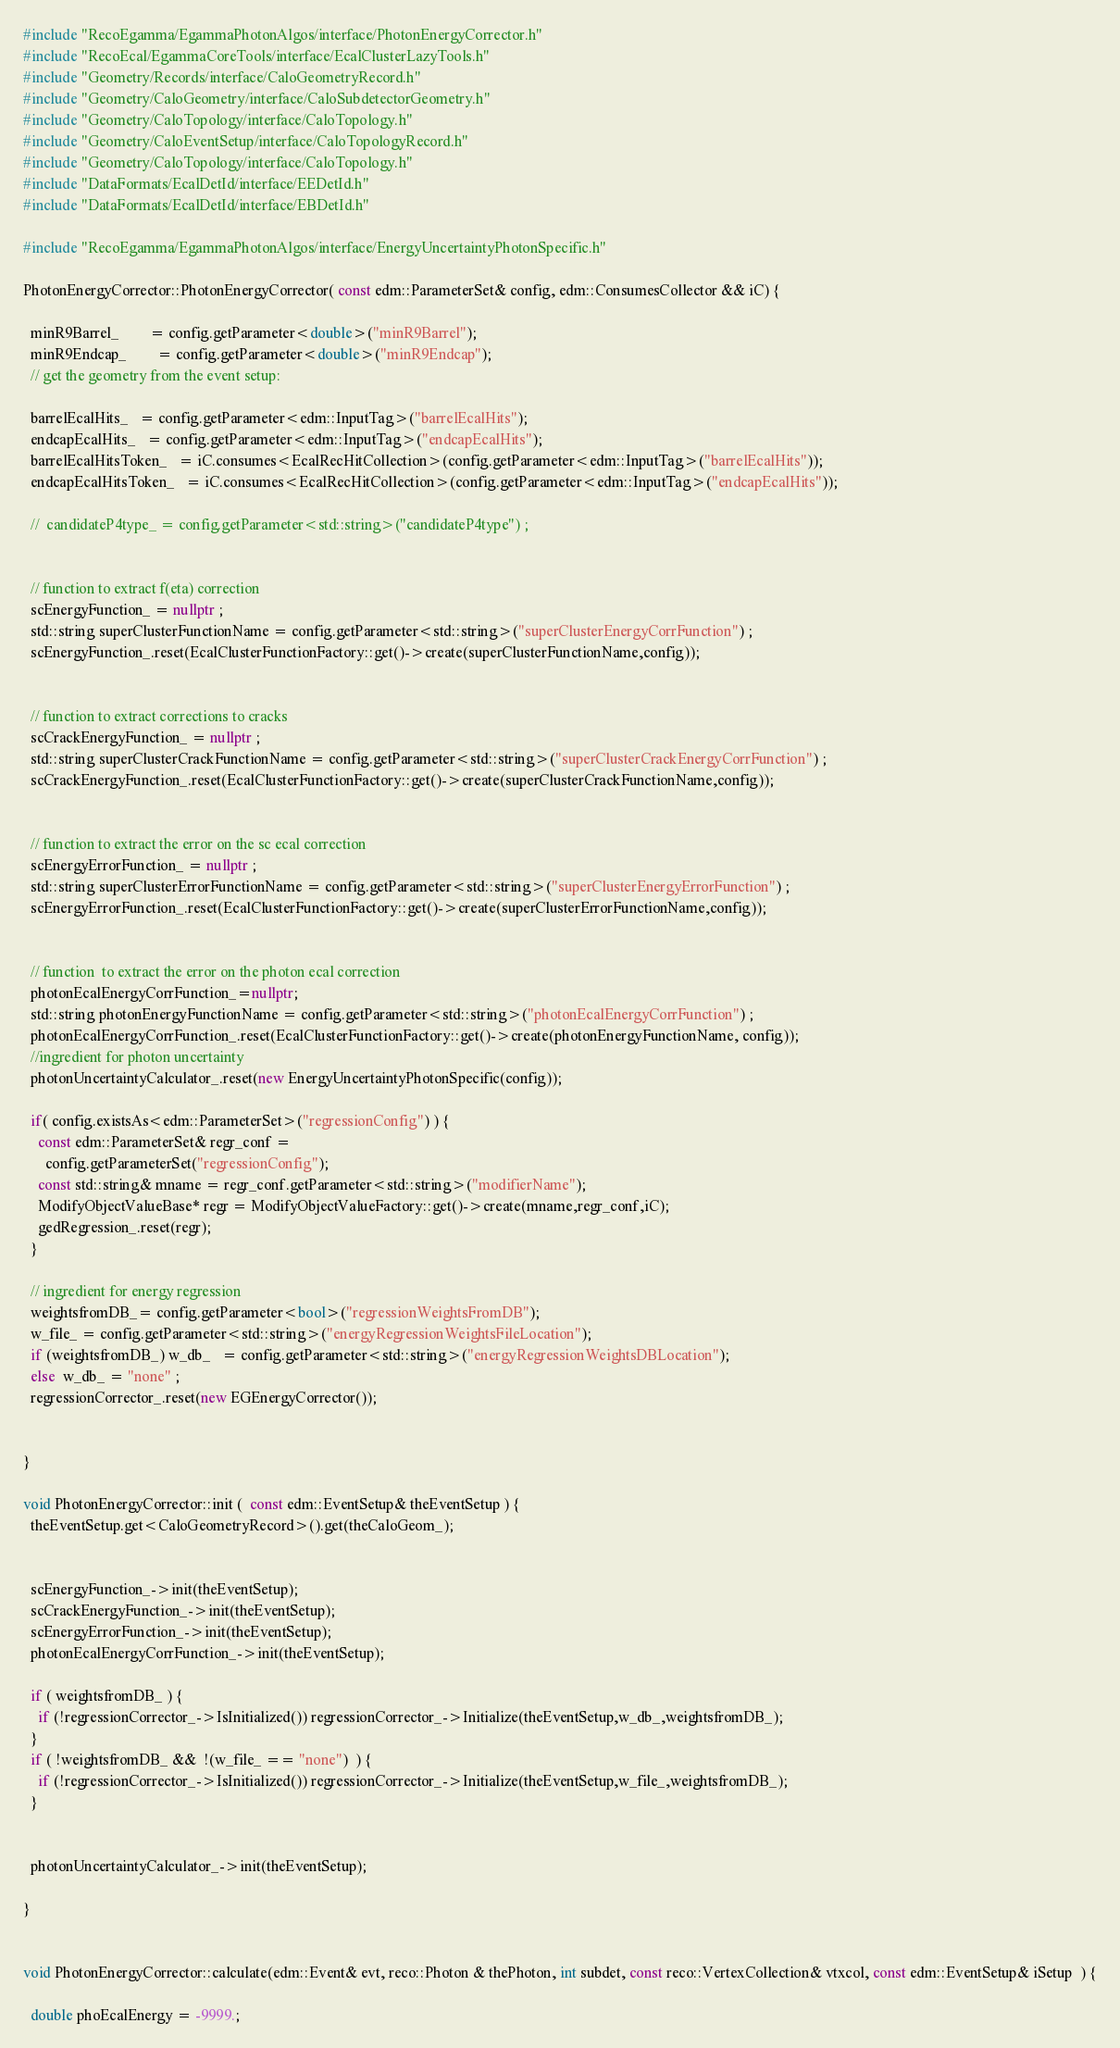Convert code to text. <code><loc_0><loc_0><loc_500><loc_500><_C++_>#include "RecoEgamma/EgammaPhotonAlgos/interface/PhotonEnergyCorrector.h"
#include "RecoEcal/EgammaCoreTools/interface/EcalClusterLazyTools.h"
#include "Geometry/Records/interface/CaloGeometryRecord.h"
#include "Geometry/CaloGeometry/interface/CaloSubdetectorGeometry.h"
#include "Geometry/CaloTopology/interface/CaloTopology.h"
#include "Geometry/CaloEventSetup/interface/CaloTopologyRecord.h"
#include "Geometry/CaloTopology/interface/CaloTopology.h"
#include "DataFormats/EcalDetId/interface/EEDetId.h"
#include "DataFormats/EcalDetId/interface/EBDetId.h"

#include "RecoEgamma/EgammaPhotonAlgos/interface/EnergyUncertaintyPhotonSpecific.h"

PhotonEnergyCorrector::PhotonEnergyCorrector( const edm::ParameterSet& config, edm::ConsumesCollector && iC) {

  minR9Barrel_        = config.getParameter<double>("minR9Barrel");
  minR9Endcap_        = config.getParameter<double>("minR9Endcap");
  // get the geometry from the event setup:

  barrelEcalHits_   = config.getParameter<edm::InputTag>("barrelEcalHits");
  endcapEcalHits_   = config.getParameter<edm::InputTag>("endcapEcalHits");
  barrelEcalHitsToken_   = iC.consumes<EcalRecHitCollection>(config.getParameter<edm::InputTag>("barrelEcalHits"));
  endcapEcalHitsToken_   = iC.consumes<EcalRecHitCollection>(config.getParameter<edm::InputTag>("endcapEcalHits"));

  //  candidateP4type_ = config.getParameter<std::string>("candidateP4type") ;


  // function to extract f(eta) correction
  scEnergyFunction_ = nullptr ;
  std::string superClusterFunctionName = config.getParameter<std::string>("superClusterEnergyCorrFunction") ;
  scEnergyFunction_.reset(EcalClusterFunctionFactory::get()->create(superClusterFunctionName,config));


  // function to extract corrections to cracks
  scCrackEnergyFunction_ = nullptr ;
  std::string superClusterCrackFunctionName = config.getParameter<std::string>("superClusterCrackEnergyCorrFunction") ;
  scCrackEnergyFunction_.reset(EcalClusterFunctionFactory::get()->create(superClusterCrackFunctionName,config));


  // function to extract the error on the sc ecal correction
  scEnergyErrorFunction_ = nullptr ;
  std::string superClusterErrorFunctionName = config.getParameter<std::string>("superClusterEnergyErrorFunction") ;
  scEnergyErrorFunction_.reset(EcalClusterFunctionFactory::get()->create(superClusterErrorFunctionName,config));


  // function  to extract the error on the photon ecal correction
  photonEcalEnergyCorrFunction_=nullptr;
  std::string photonEnergyFunctionName = config.getParameter<std::string>("photonEcalEnergyCorrFunction") ;
  photonEcalEnergyCorrFunction_.reset(EcalClusterFunctionFactory::get()->create(photonEnergyFunctionName, config));
  //ingredient for photon uncertainty
  photonUncertaintyCalculator_.reset(new EnergyUncertaintyPhotonSpecific(config));
 
  if( config.existsAs<edm::ParameterSet>("regressionConfig") ) {
    const edm::ParameterSet& regr_conf = 
      config.getParameterSet("regressionConfig");
    const std::string& mname = regr_conf.getParameter<std::string>("modifierName");
    ModifyObjectValueBase* regr = ModifyObjectValueFactory::get()->create(mname,regr_conf,iC);
    gedRegression_.reset(regr);
  }

  // ingredient for energy regression
  weightsfromDB_= config.getParameter<bool>("regressionWeightsFromDB");
  w_file_ = config.getParameter<std::string>("energyRegressionWeightsFileLocation");
  if (weightsfromDB_) w_db_   = config.getParameter<std::string>("energyRegressionWeightsDBLocation");
  else  w_db_ = "none" ;
  regressionCorrector_.reset(new EGEnergyCorrector()); 


}

void PhotonEnergyCorrector::init (  const edm::EventSetup& theEventSetup ) {
  theEventSetup.get<CaloGeometryRecord>().get(theCaloGeom_);


  scEnergyFunction_->init(theEventSetup); 
  scCrackEnergyFunction_->init(theEventSetup); 
  scEnergyErrorFunction_->init(theEventSetup); 
  photonEcalEnergyCorrFunction_->init(theEventSetup);

  if ( weightsfromDB_ ) {
    if (!regressionCorrector_->IsInitialized()) regressionCorrector_->Initialize(theEventSetup,w_db_,weightsfromDB_);
  }
  if ( !weightsfromDB_ &&  !(w_file_ == "none")  ) {
    if (!regressionCorrector_->IsInitialized()) regressionCorrector_->Initialize(theEventSetup,w_file_,weightsfromDB_);
  }  

 
  photonUncertaintyCalculator_->init(theEventSetup);
  
}


void PhotonEnergyCorrector::calculate(edm::Event& evt, reco::Photon & thePhoton, int subdet, const reco::VertexCollection& vtxcol, const edm::EventSetup& iSetup  ) {
  
  double phoEcalEnergy = -9999.;</code> 